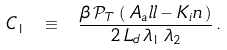<formula> <loc_0><loc_0><loc_500><loc_500>C _ { 1 } \ \equiv \ \frac { \beta \, \mathcal { P } _ { T } \, \left ( \, A _ { a } l l - K _ { i } n \, \right ) } { 2 \, L _ { d } \, \lambda _ { 1 } \, \lambda _ { 2 } } \, .</formula> 